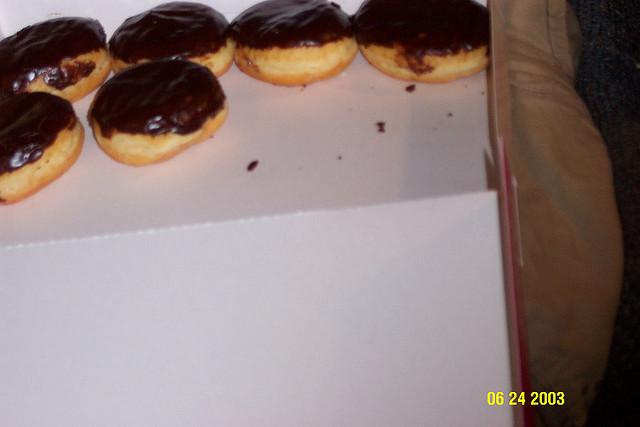Are these Boston creme donuts?
Quick response, please. Yes. When was the picture taken?
Short answer required. June 24 2003. Where are the donuts from?
Quick response, please. Dunkin donuts. What is on top of the donuts?
Answer briefly. Chocolate. 